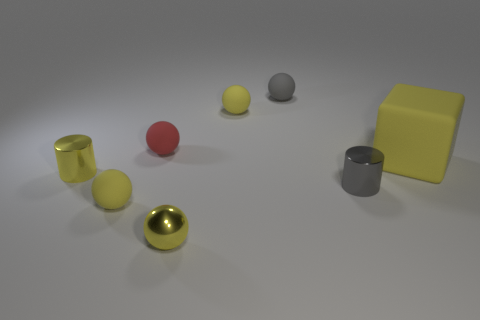Do the gray metallic object and the red thing have the same size?
Give a very brief answer. Yes. There is a small rubber ball in front of the large object; what color is it?
Offer a very short reply. Yellow. Are there any other tiny balls that have the same color as the metal sphere?
Keep it short and to the point. Yes. There is a metallic ball that is the same size as the red rubber ball; what is its color?
Your response must be concise. Yellow. Is the big yellow rubber thing the same shape as the gray metallic thing?
Provide a succinct answer. No. There is a yellow ball behind the small yellow metal cylinder; what is it made of?
Provide a succinct answer. Rubber. The large thing is what color?
Ensure brevity in your answer.  Yellow. Do the gray object in front of the tiny red sphere and the yellow rubber ball behind the small gray cylinder have the same size?
Provide a succinct answer. Yes. There is a yellow matte object that is both to the left of the large matte object and behind the yellow cylinder; what is its size?
Give a very brief answer. Small. The other small metallic object that is the same shape as the red thing is what color?
Provide a short and direct response. Yellow. 